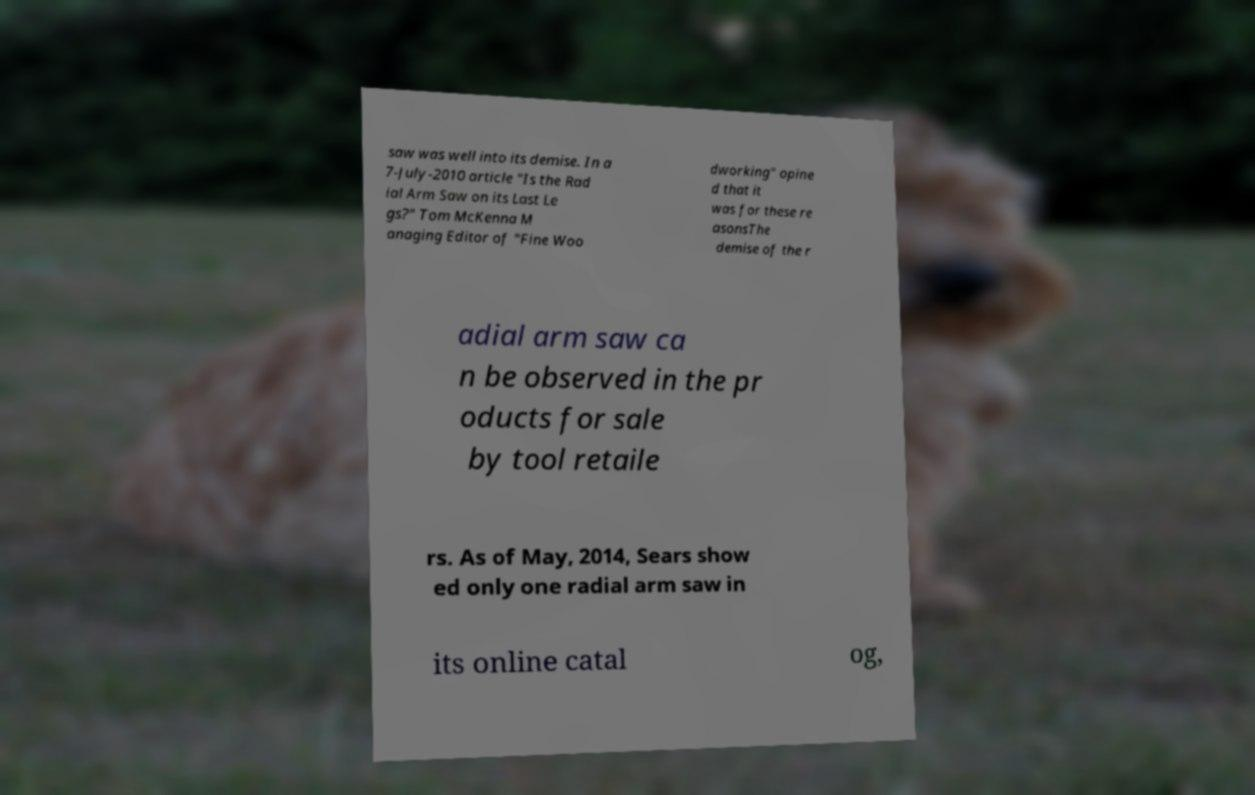I need the written content from this picture converted into text. Can you do that? saw was well into its demise. In a 7-July-2010 article "Is the Rad ial Arm Saw on its Last Le gs?" Tom McKenna M anaging Editor of "Fine Woo dworking" opine d that it was for these re asonsThe demise of the r adial arm saw ca n be observed in the pr oducts for sale by tool retaile rs. As of May, 2014, Sears show ed only one radial arm saw in its online catal og, 